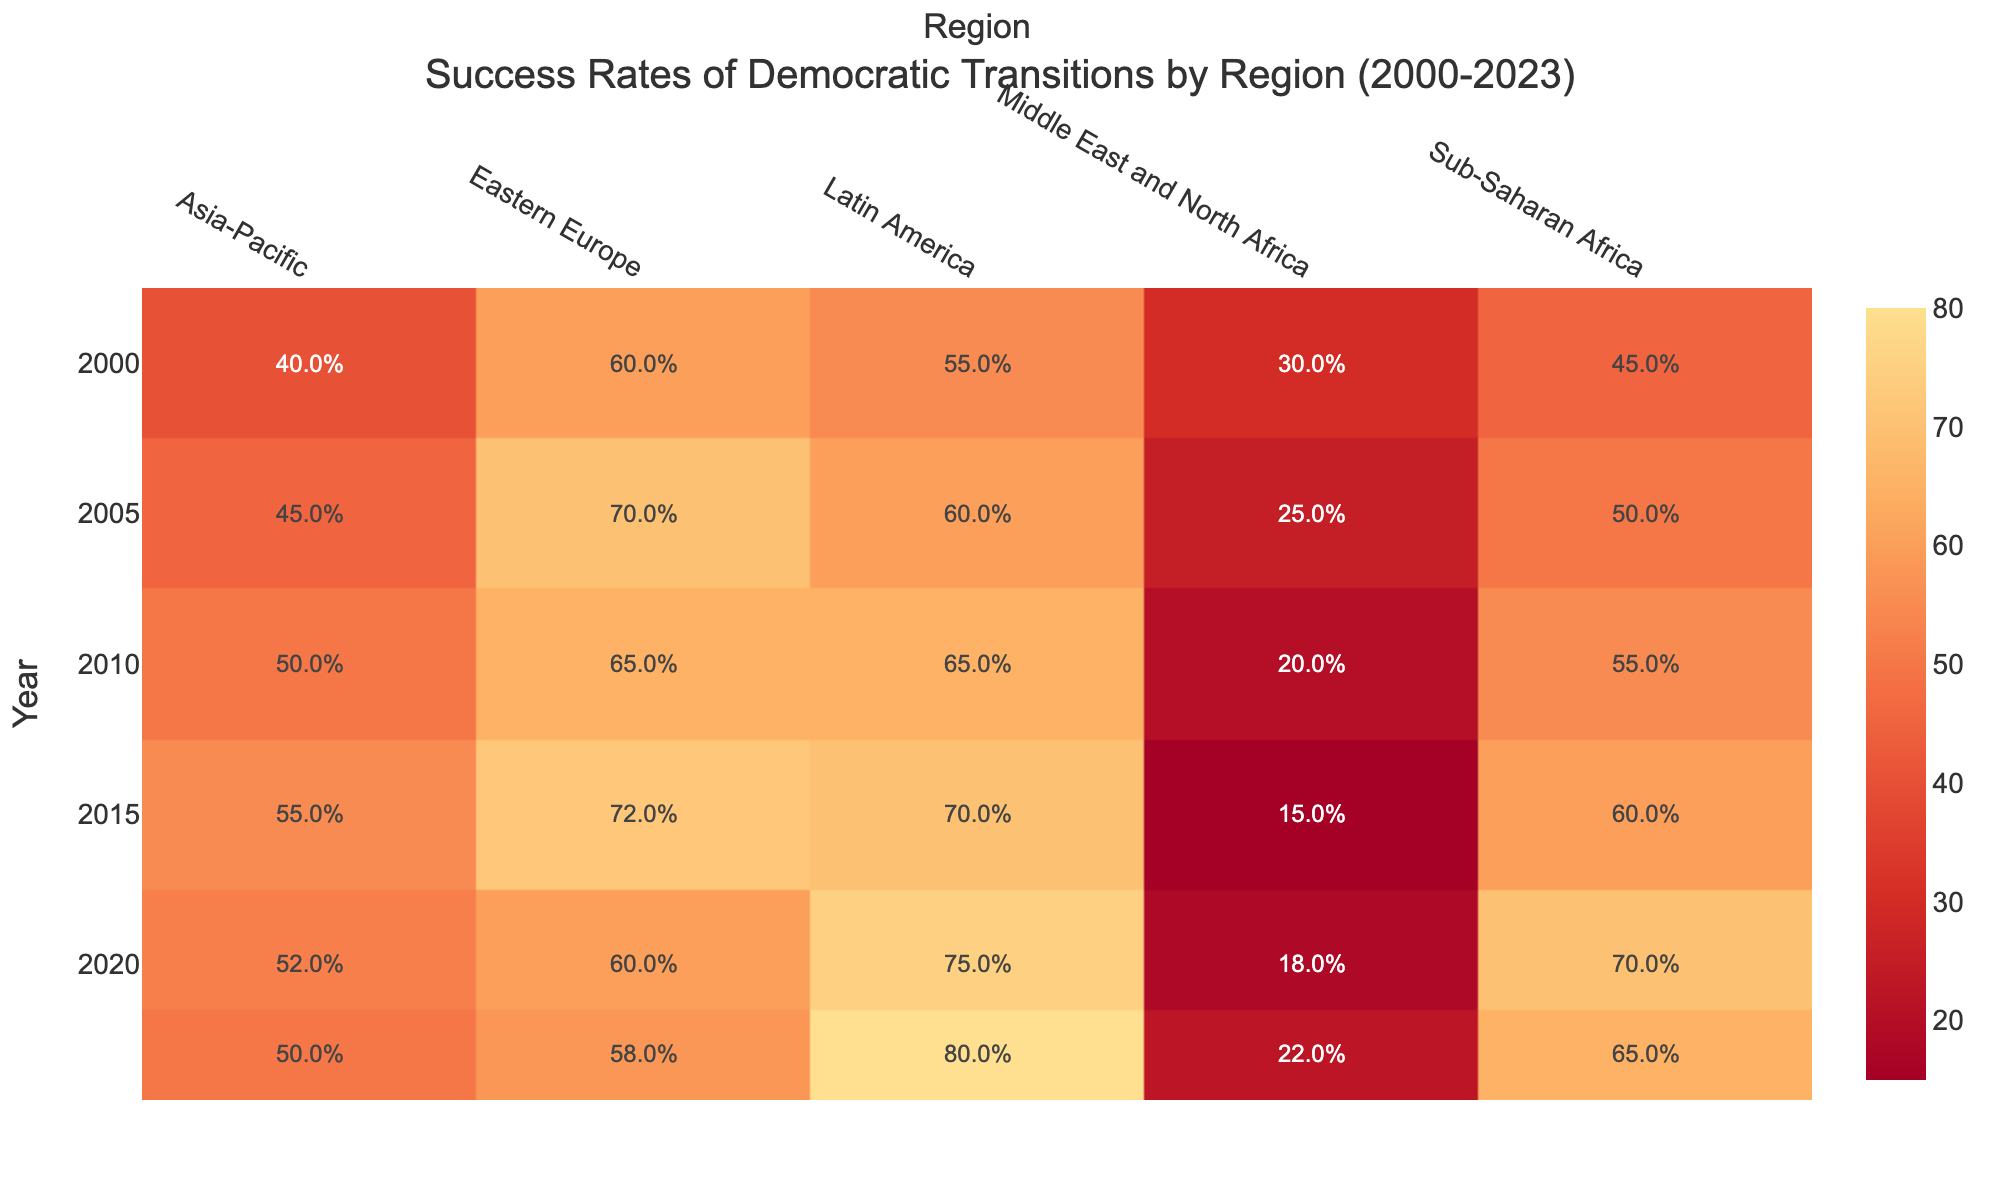What was the success rate of democratic transitions in Latin America in 2020? According to the table, in 2020, the success rate for Latin America is listed as 75.0%.
Answer: 75.0% Which region had the lowest success rate in 2010? By examining the data for 2010, we see the regions listed along with their success rates: Sub-Saharan Africa (55.0%), Eastern Europe (65.0%), Asia-Pacific (50.0%), Middle East and North Africa (20.0%), and Latin America (65.0%). The lowest rate is in the Middle East and North Africa, at 20.0%.
Answer: Middle East and North Africa What is the average success rate of democratic transitions in Sub-Saharan Africa from 2000 to 2023? The success rates for Sub-Saharan Africa over the years are: 45.0%, 50.0%, 55.0%, 60.0%, 70.0%, and 65.0%. Adding these gives 45.0 + 50.0 + 55.0 + 60.0 + 70.0 + 65.0 = 345.0. Dividing by the number of years (6), the average is 345.0 / 6 = 57.5.
Answer: 57.5 Did the success rate for democratic transitions in Eastern Europe increase, decrease, or remain the same from 2005 to 2023? We check the success rates for Eastern Europe in 2005, which is 70.0%, compared to 58.0% in 2023. Since 58.0% is lower than 70.0%, the rate decreased.
Answer: Decreased Which region saw the highest increase in success rate from 2000 to 2020? First, we determine the success rates for each region in 2000 and 2020: Sub-Saharan Africa (45.0% to 70.0%), Eastern Europe (60.0% to 60.0%), Asia-Pacific (40.0% to 52.0%), Middle East and North Africa (30.0% to 18.0%), and Latin America (55.0% to 75.0%). The largest increase is for Sub-Saharan Africa: 70.0% - 45.0% = 25.0%. Thus, the highest increase is 25.0%.
Answer: Sub-Saharan Africa What was the success rate in the Asia-Pacific region in 2023? Checking the table, the success rate for the Asia-Pacific region in 2023 is 50.0%.
Answer: 50.0% 